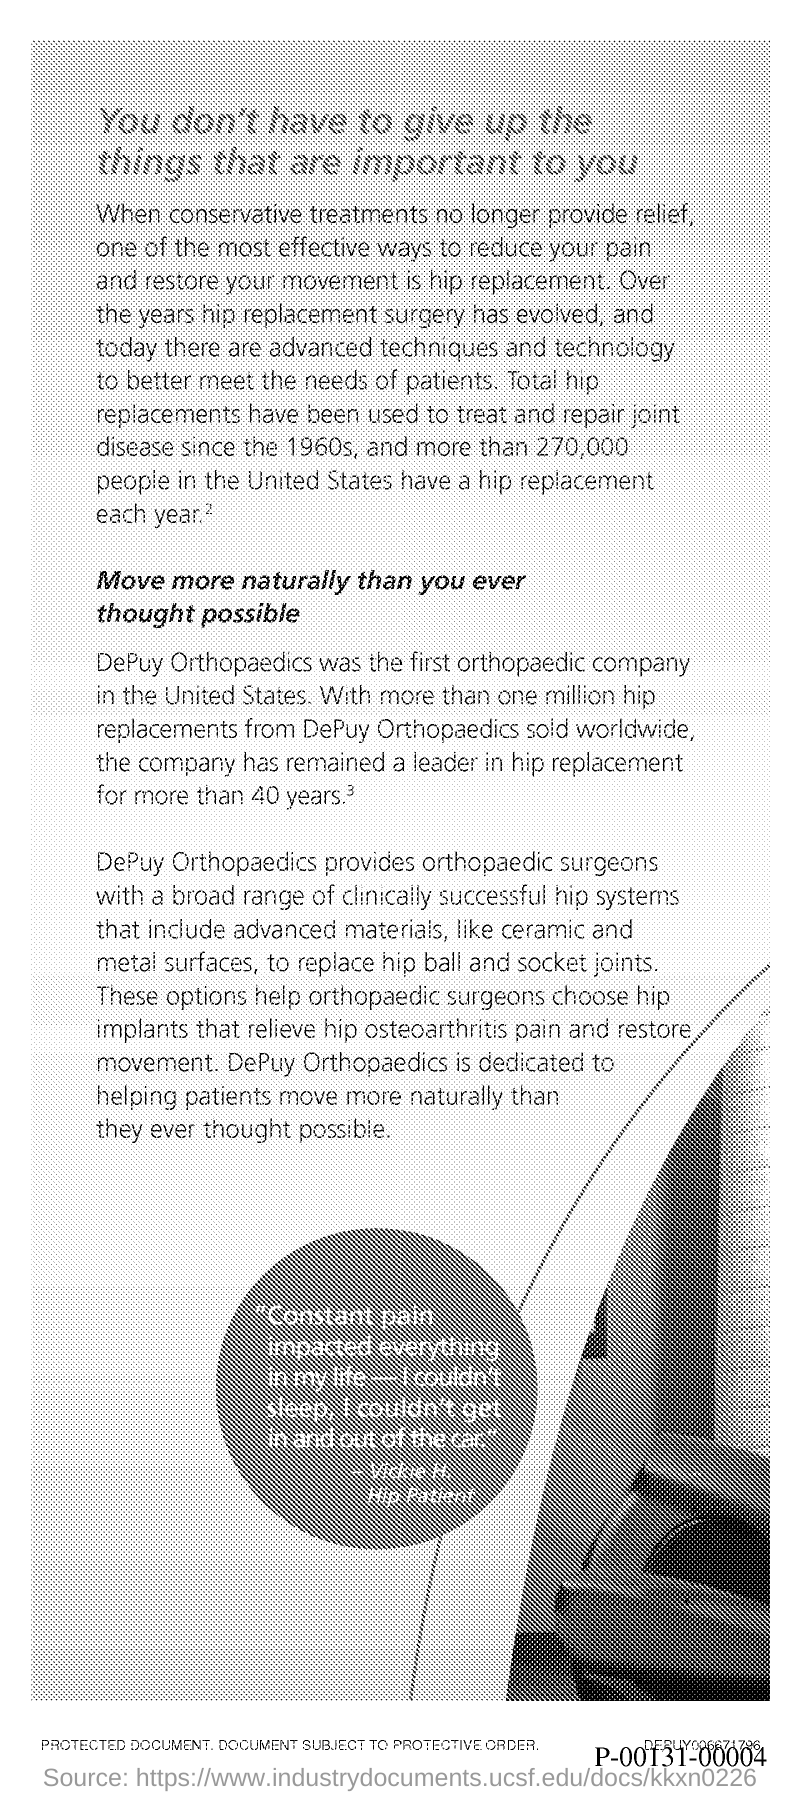Give some essential details in this illustration. DEPUY ORTHOPAEDICS was the first orthopaedic company in the United States. 